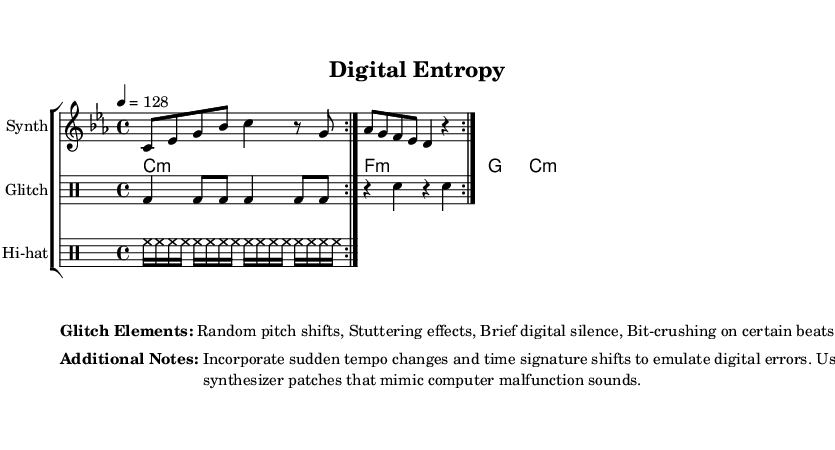What is the key signature of this music? The key signature is C minor, which has three flats (B♭, E♭, A♭) indicated in the key signature at the beginning of the staff.
Answer: C minor What is the time signature of this music? The time signature is shown as 4/4, indicating four beats per measure and a quarter note receives one beat, which is a common time signature for many musical styles including electronic music.
Answer: 4/4 What is the tempo marking for this piece? The tempo is marked as 4 = 128, which indicates that there are 128 beats per minute when the quarter note is played at the specified speed.
Answer: 128 How many measures are repeated in the main part of the music? The music contains a repeat marking, indicated by "volta 2," which shows that the two measures will be played twice before moving on. Therefore, the repeated section consists of 2 measures.
Answer: 2 What kind of effects are mentioned in the "Glitch Elements" section? The "Glitch Elements" describe specific effects that are characteristic of glitch-hop fusion; these include random pitch shifts, stuttering effects, brief digital silence, and bit-crushing on certain beats.
Answer: Random pitch shifts, Stuttering effects, Brief digital silence, Bit-crushing What additional techniques are suggested for emulating digital errors? The additional notes mention incorporating sudden tempo changes and time signature shifts, as well as using synthesizer patches that mimic computer malfunction sounds, which are crucial for fitting the glitch-hop genre.
Answer: Sudden tempo changes and time signature shifts What type of instrument is the staff labeled "Hi-hat" representing? The staff labeled "Hi-hat" represents a specific type of percussion instrument that plays rapid sequences, typically used in electronic music to provide a consistent rhythmic backdrop.
Answer: Hi-hat 